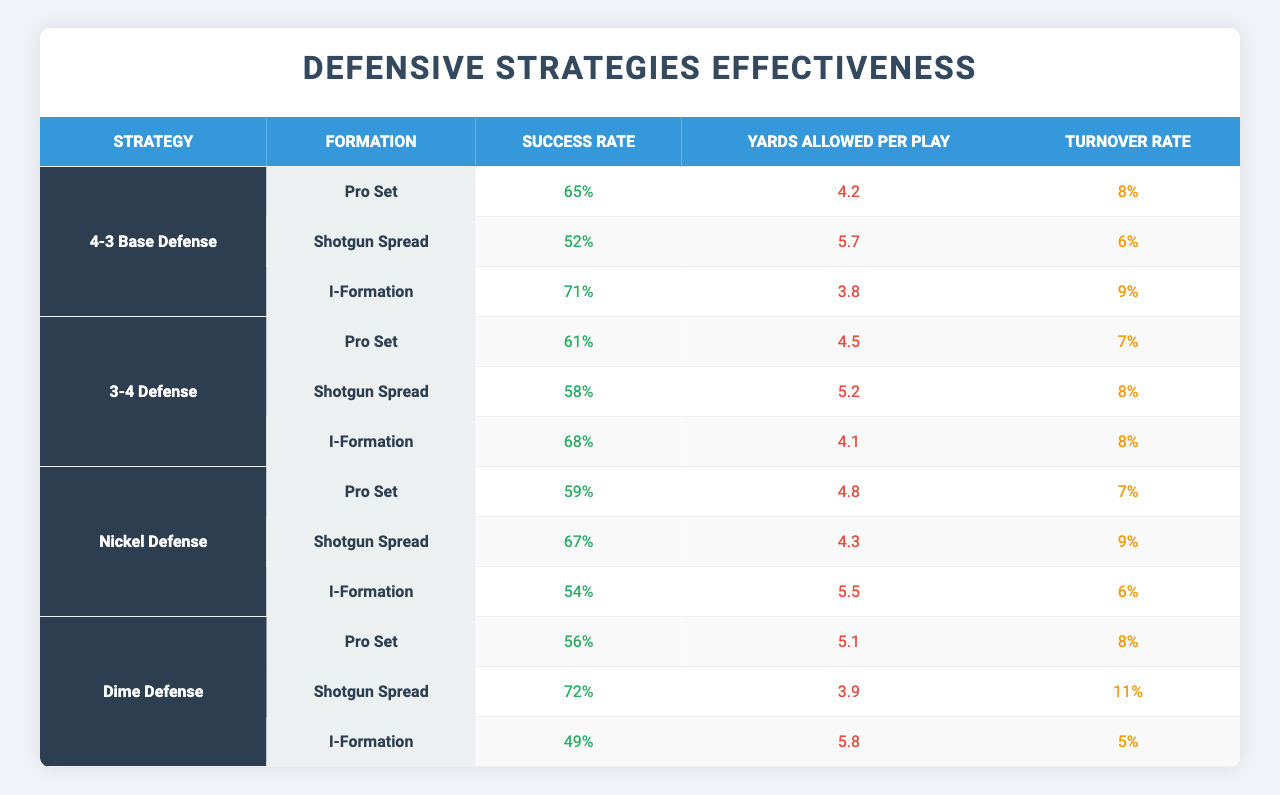What is the success rate of the 4-3 Base Defense against the I-Formation? The success rate for the 4-3 Base Defense against the I-Formation is listed directly in the table, which shows a success rate of 71%.
Answer: 71% Which defensive strategy has the highest success rate against the Shotgun Spread formation? By comparing the success rates for the Shotgun Spread formation across all defensive strategies in the table, the Dime Defense has the highest success rate at 72%.
Answer: Dime Defense What is the average yards allowed per play for the 3-4 Defense against all formations? To calculate the average yards allowed per play for the 3-4 Defense, add the yards allowed per play for each formation (4.5 + 5.2 + 4.1 = 13.8) and then divide by the number of formations (3). So, the average is 13.8 / 3 = 4.6 yards allowed per play.
Answer: 4.6 Which formation is most effectively defended by the Nickel Defense based on the turnover rate? The turnover rate for each formation against the Nickel Defense shows that the Shotgun Spread formation has the highest turnover rate at 9%, indicating it is the most effectively defended against by this strategy in terms of turnovers.
Answer: Shotgun Spread Is the success rate of the Dime Defense against the Pro Set lower than the success rate of the 3-4 Defense against the same formation? The Dime Defense has a success rate of 56% against the Pro Set, while the 3-4 Defense has a success rate of 61%. Since 56% is lower than 61%, the statement is true.
Answer: Yes What is the difference in yards allowed per play between the 4-3 Base Defense and the Dime Defense against the Shotgun Spread formation? The 4-3 Base Defense allows 5.7 yards per play against the Shotgun Spread, while the Dime Defense allows 3.9 yards per play. The difference is calculated as 5.7 - 3.9 = 1.8 yards.
Answer: 1.8 Which defensive strategy has the lowest success rate overall across all formations? By assessing the success rates of each defensive strategy against all formations, the Dime Defense has the overall lowest success rate, specifically noted for the I-Formation at 49%.
Answer: Dime Defense How many defensive strategies had a success rate of over 60% against the Pro Set formation? The strategies with success rates over 60% against the Pro Set are the 4-3 Base Defense (65%), 3-4 Defense (61%), and Nickel Defense (59%, so not counted). Hence, there are two strategies that meet the requirement.
Answer: 2 